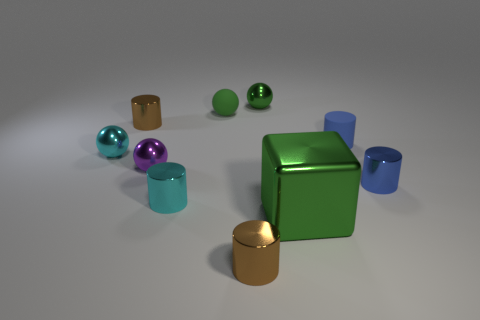Is there any other thing that has the same color as the rubber cylinder?
Your answer should be very brief. Yes. What is the color of the rubber sphere behind the small cyan shiny object that is behind the small purple shiny ball?
Offer a terse response. Green. Are there fewer blue objects that are in front of the blue rubber object than small purple metal objects that are on the right side of the tiny green rubber ball?
Your answer should be compact. No. There is a thing that is the same color as the matte cylinder; what is its material?
Offer a terse response. Metal. What number of objects are either purple things behind the large green shiny cube or tiny rubber objects?
Offer a terse response. 3. Do the blue thing in front of the purple metal sphere and the cyan cylinder have the same size?
Your answer should be very brief. Yes. Is the number of cyan shiny things behind the green metallic sphere less than the number of red balls?
Make the answer very short. No. There is a purple thing that is the same size as the blue rubber cylinder; what material is it?
Provide a short and direct response. Metal. How many large things are either purple metal balls or blue objects?
Your answer should be very brief. 0. What number of things are blue shiny objects in front of the purple shiny sphere or spheres to the right of the tiny purple sphere?
Ensure brevity in your answer.  3. 